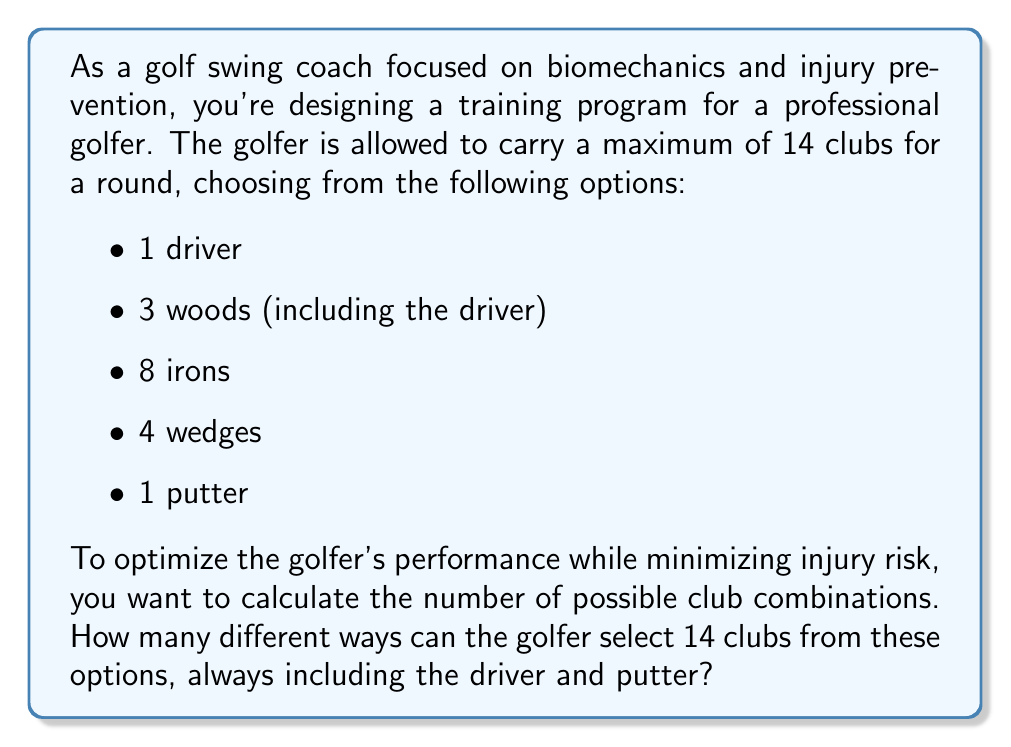Give your solution to this math problem. Let's approach this step-by-step:

1) The driver and putter are always included, so we need to select 12 more clubs from the remaining options.

2) We have the following choices:
   - 2 woods (since the driver is already included)
   - 8 irons
   - 4 wedges

3) This is a combination problem where we need to select clubs from each category. We can use the multiplication principle.

4) Let's break it down:
   a) Woods: We need to choose 0, 1, or 2 woods from the 2 available.
   b) Irons: We can choose any number from 0 to 8 irons.
   c) Wedges: We can choose any number from 0 to 4 wedges.

5) The total number of clubs selected (woods + irons + wedges) must equal 12.

6) We can express this mathematically:

   $$ \sum_{w=0}^2 \sum_{i=0}^8 \sum_{j=0}^4 [w + i + j = 12] \binom{2}{w} \binom{8}{i} \binom{4}{j} $$

   Where $[w + i + j = 12]$ is the Iverson bracket, equal to 1 when the condition is true and 0 otherwise.

7) Expanding this:
   - For 0 woods: $\binom{2}{0} \binom{8}{8} \binom{4}{4} + \binom{2}{0} \binom{8}{9} \binom{4}{3} + \binom{2}{0} \binom{8}{10} \binom{4}{2} + \binom{2}{0} \binom{8}{11} \binom{4}{1} + \binom{2}{0} \binom{8}{12} \binom{4}{0}$
   - For 1 wood: $\binom{2}{1} \binom{8}{7} \binom{4}{4} + \binom{2}{1} \binom{8}{8} \binom{4}{3} + \binom{2}{1} \binom{8}{9} \binom{4}{2} + \binom{2}{1} \binom{8}{10} \binom{4}{1} + \binom{2}{1} \binom{8}{11} \binom{4}{0}$
   - For 2 woods: $\binom{2}{2} \binom{8}{6} \binom{4}{4} + \binom{2}{2} \binom{8}{7} \binom{4}{3} + \binom{2}{2} \binom{8}{8} \binom{4}{2} + \binom{2}{2} \binom{8}{9} \binom{4}{1} + \binom{2}{2} \binom{8}{10} \binom{4}{0}$

8) Calculating each term and summing:
   $1 \cdot 1 \cdot 1 + 1 \cdot 8 \cdot 4 + 1 \cdot 28 \cdot 6 + 1 \cdot 56 \cdot 4 + 1 \cdot 70 \cdot 1 +$
   $2 \cdot 8 \cdot 1 + 2 \cdot 28 \cdot 4 + 2 \cdot 56 \cdot 6 + 2 \cdot 70 \cdot 4 + 2 \cdot 56 \cdot 1 +$
   $1 \cdot 28 \cdot 1 + 1 \cdot 56 \cdot 4 + 1 \cdot 70 \cdot 6 + 1 \cdot 56 \cdot 4 + 1 \cdot 28 \cdot 1$

   $= 1 + 32 + 168 + 224 + 70 + 16 + 224 + 672 + 560 + 112 + 28 + 224 + 420 + 224 + 28$

   $= 3003$
Answer: There are 3003 different ways to select 14 clubs for a round of golf, always including the driver and putter. 